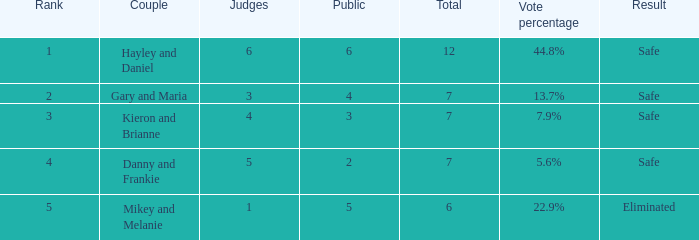What was the top rank for the vote percentage of 4.0. 